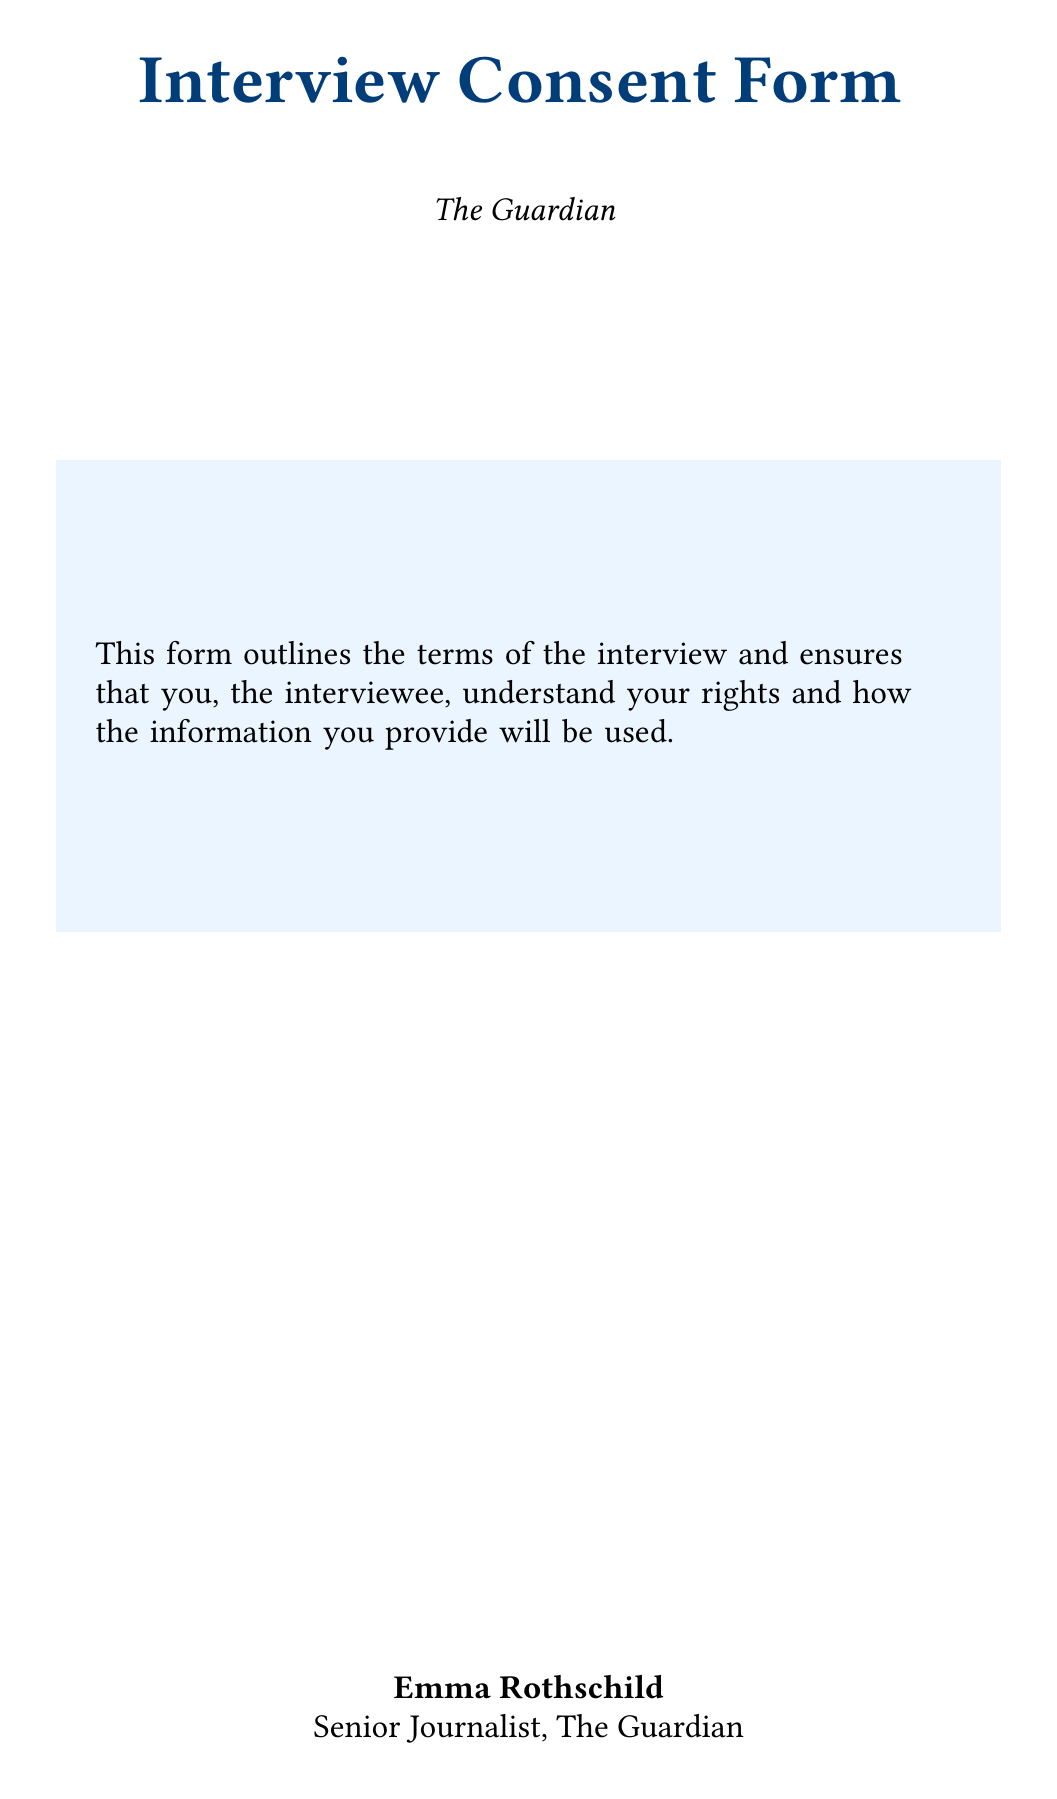what is the name of the interviewer? The name of the interviewer is provided in the document, which is a key detail about the interview process.
Answer: Emma Rothschild what is the position of the interviewer? The position of the interviewer is specified in the document, indicating the professional role held by the individual conducting the interview.
Answer: Senior Journalist what is the primary purpose of this document? The purpose statement outlines the main goal of the form, helping to clarify the intention behind collecting consent from the interviewee.
Answer: This form outlines the terms of the interview and ensures that you, the interviewee, understand your rights and how the information you provide will be used how many days do you have to withdraw your consent? The document specifies the time frame within which the interviewee can reconsider their consent, an important aspect of participant rights.
Answer: 14 days what shall be done if anonymity is requested? This detail explains the protocol to follow in the event that an interviewee wishes to remain anonymous, highlighting the confidentiality measures in place.
Answer: A pseudonym will be used in the published article how is sensitive information treated according to the form? The confidentiality section outlines the treatment of sensitive information, emphasizing the commitment to protect the interviewee’s privacy.
Answer: Sensitive information you provide off-the-record will remain confidential what is the ethical consideration highlighted in the document? This section discusses the ethical standards that the interview process adheres to, showcasing the commitment to integrity in journalism.
Answer: This interview adheres to the Society of Professional Journalists Code of Ethics who can be contacted for ethical concerns? The contact information provides clarity on who to reach out to regarding ethical inquiries or issues that may arise.
Answer: John Stuart Mill 